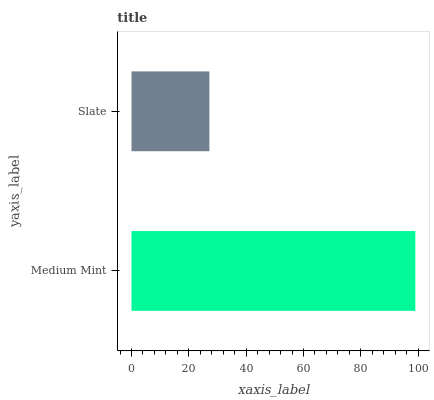Is Slate the minimum?
Answer yes or no. Yes. Is Medium Mint the maximum?
Answer yes or no. Yes. Is Slate the maximum?
Answer yes or no. No. Is Medium Mint greater than Slate?
Answer yes or no. Yes. Is Slate less than Medium Mint?
Answer yes or no. Yes. Is Slate greater than Medium Mint?
Answer yes or no. No. Is Medium Mint less than Slate?
Answer yes or no. No. Is Medium Mint the high median?
Answer yes or no. Yes. Is Slate the low median?
Answer yes or no. Yes. Is Slate the high median?
Answer yes or no. No. Is Medium Mint the low median?
Answer yes or no. No. 